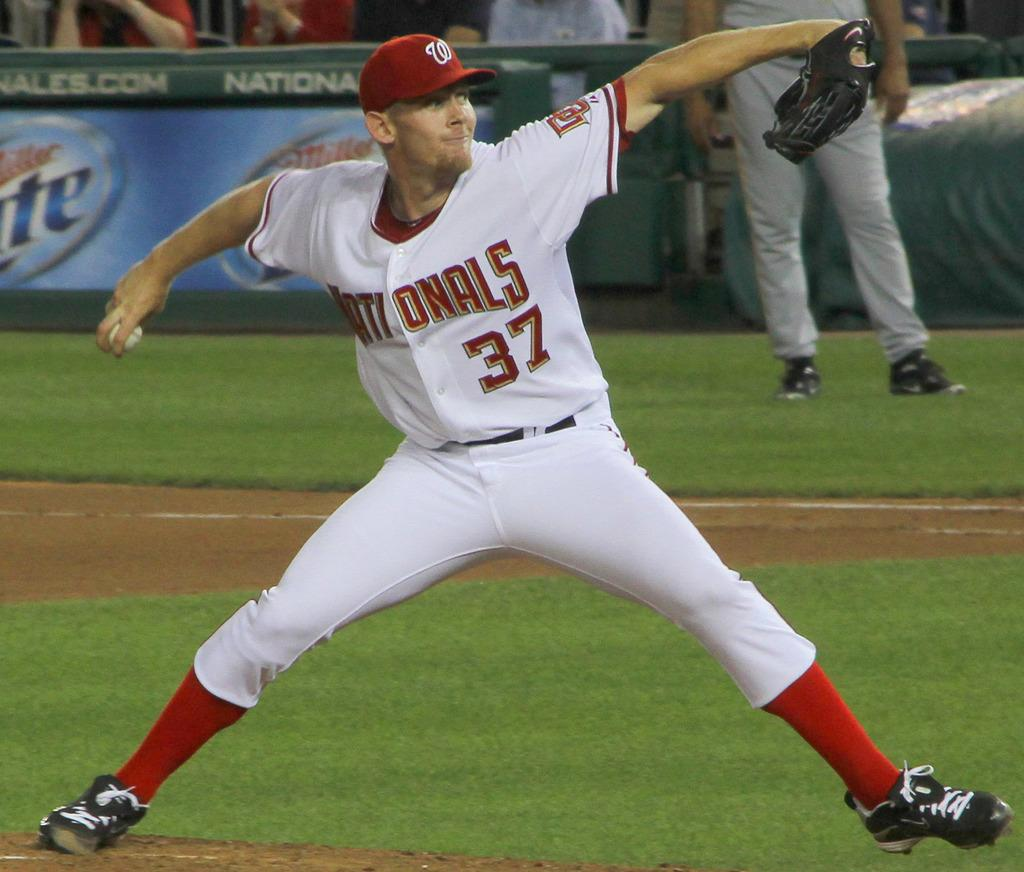Provide a one-sentence caption for the provided image. A baseball player for the Nationals pitching with his right hand. 